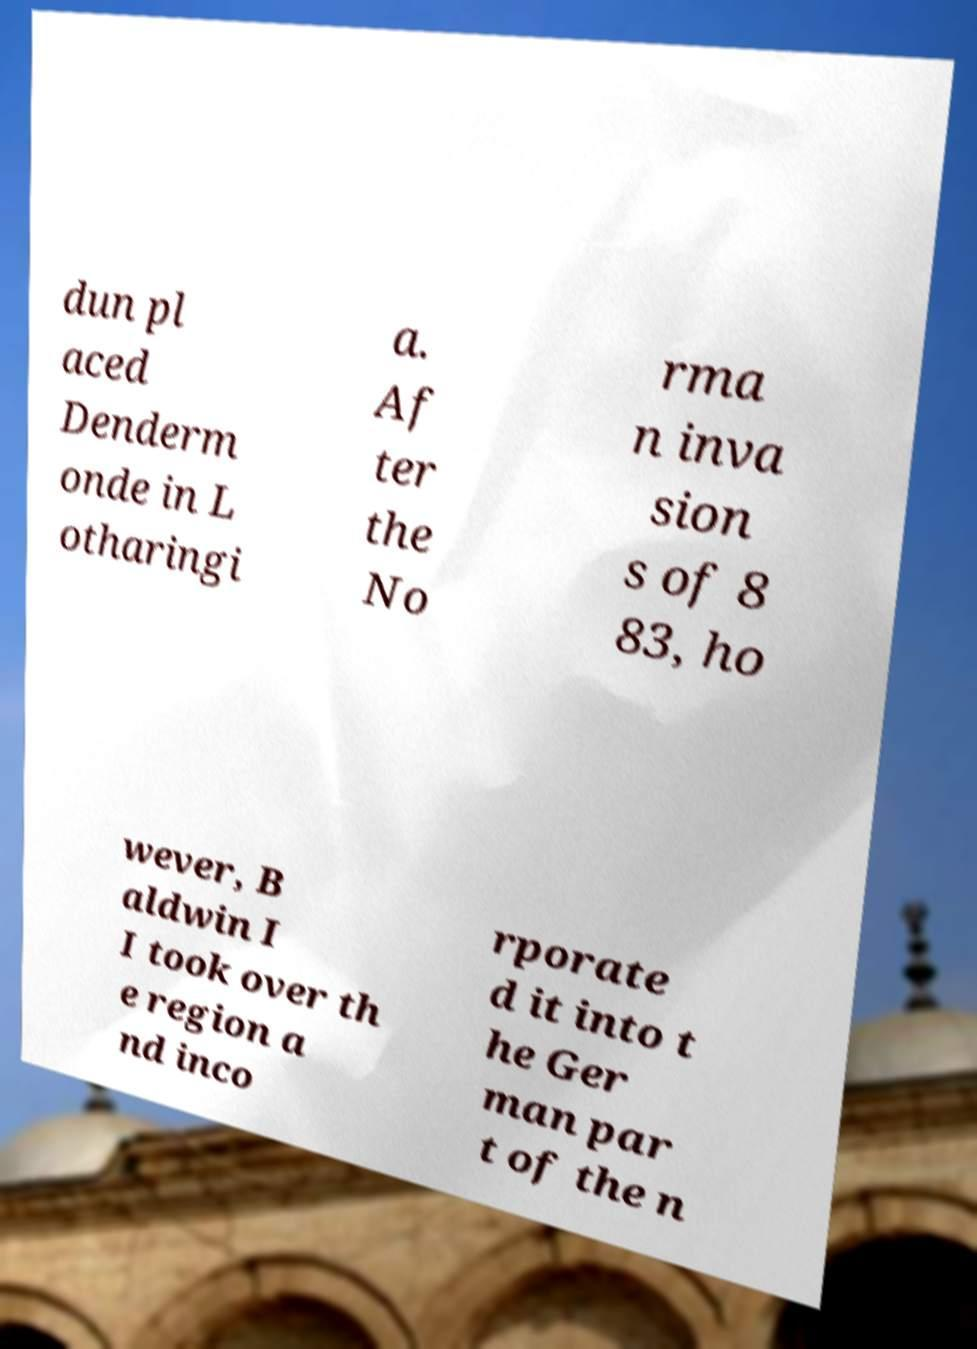Could you assist in decoding the text presented in this image and type it out clearly? dun pl aced Denderm onde in L otharingi a. Af ter the No rma n inva sion s of 8 83, ho wever, B aldwin I I took over th e region a nd inco rporate d it into t he Ger man par t of the n 